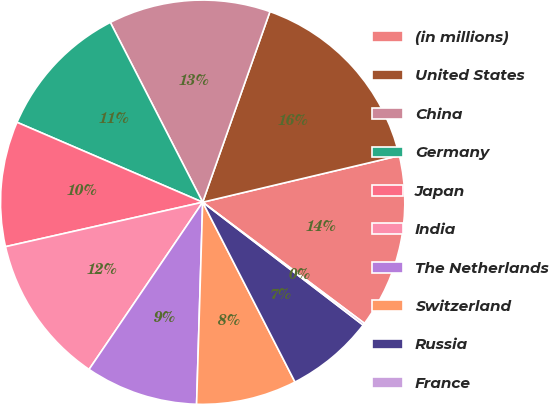Convert chart. <chart><loc_0><loc_0><loc_500><loc_500><pie_chart><fcel>(in millions)<fcel>United States<fcel>China<fcel>Germany<fcel>Japan<fcel>India<fcel>The Netherlands<fcel>Switzerland<fcel>Russia<fcel>France<nl><fcel>13.93%<fcel>15.9%<fcel>12.95%<fcel>10.98%<fcel>10.0%<fcel>11.97%<fcel>9.02%<fcel>8.03%<fcel>7.05%<fcel>0.17%<nl></chart> 